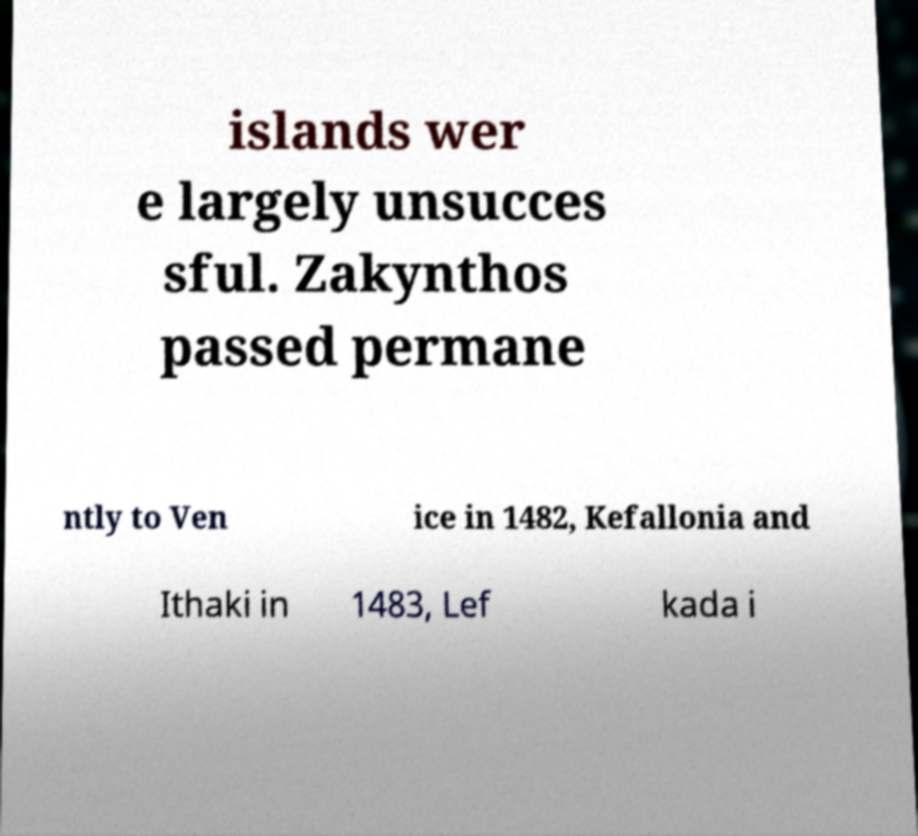I need the written content from this picture converted into text. Can you do that? islands wer e largely unsucces sful. Zakynthos passed permane ntly to Ven ice in 1482, Kefallonia and Ithaki in 1483, Lef kada i 